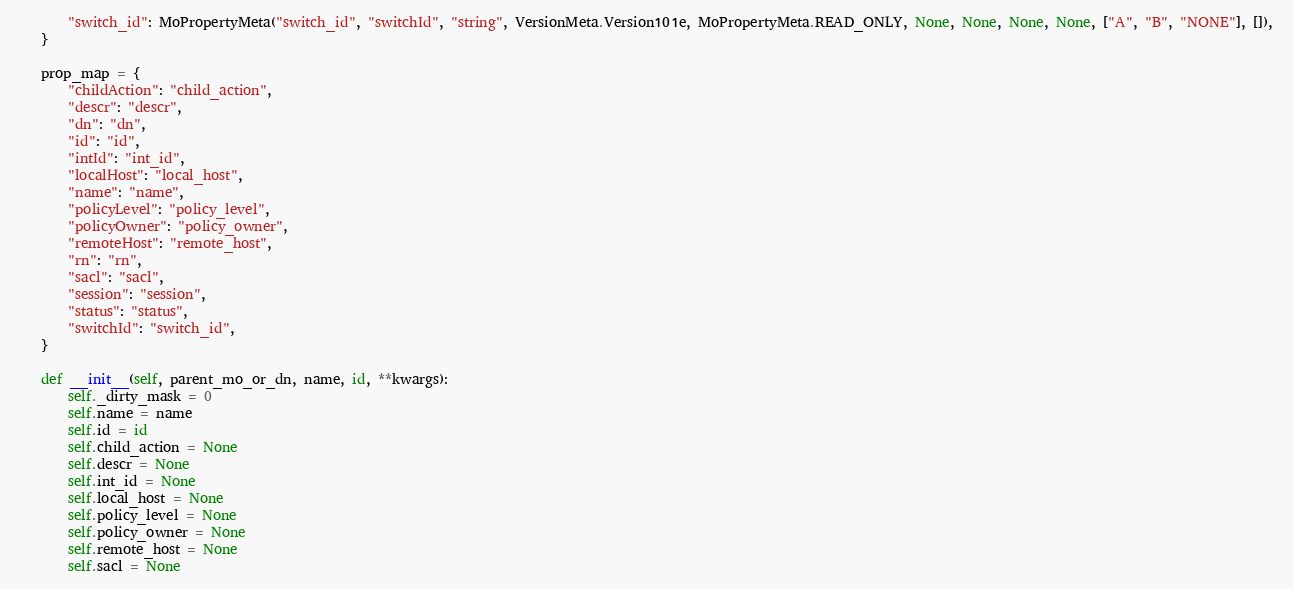<code> <loc_0><loc_0><loc_500><loc_500><_Python_>        "switch_id": MoPropertyMeta("switch_id", "switchId", "string", VersionMeta.Version101e, MoPropertyMeta.READ_ONLY, None, None, None, None, ["A", "B", "NONE"], []), 
    }

    prop_map = {
        "childAction": "child_action", 
        "descr": "descr", 
        "dn": "dn", 
        "id": "id", 
        "intId": "int_id", 
        "localHost": "local_host", 
        "name": "name", 
        "policyLevel": "policy_level", 
        "policyOwner": "policy_owner", 
        "remoteHost": "remote_host", 
        "rn": "rn", 
        "sacl": "sacl", 
        "session": "session", 
        "status": "status", 
        "switchId": "switch_id", 
    }

    def __init__(self, parent_mo_or_dn, name, id, **kwargs):
        self._dirty_mask = 0
        self.name = name
        self.id = id
        self.child_action = None
        self.descr = None
        self.int_id = None
        self.local_host = None
        self.policy_level = None
        self.policy_owner = None
        self.remote_host = None
        self.sacl = None</code> 